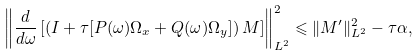<formula> <loc_0><loc_0><loc_500><loc_500>\left \| \frac { d } { d \omega } \left [ \left ( I + \tau [ P ( \omega ) \Omega _ { x } + Q ( \omega ) \Omega _ { y } ] \right ) M \right ] \right \| _ { L ^ { 2 } } ^ { 2 } \leqslant \| M ^ { \prime } \| _ { L ^ { 2 } } ^ { 2 } - \tau \alpha ,</formula> 